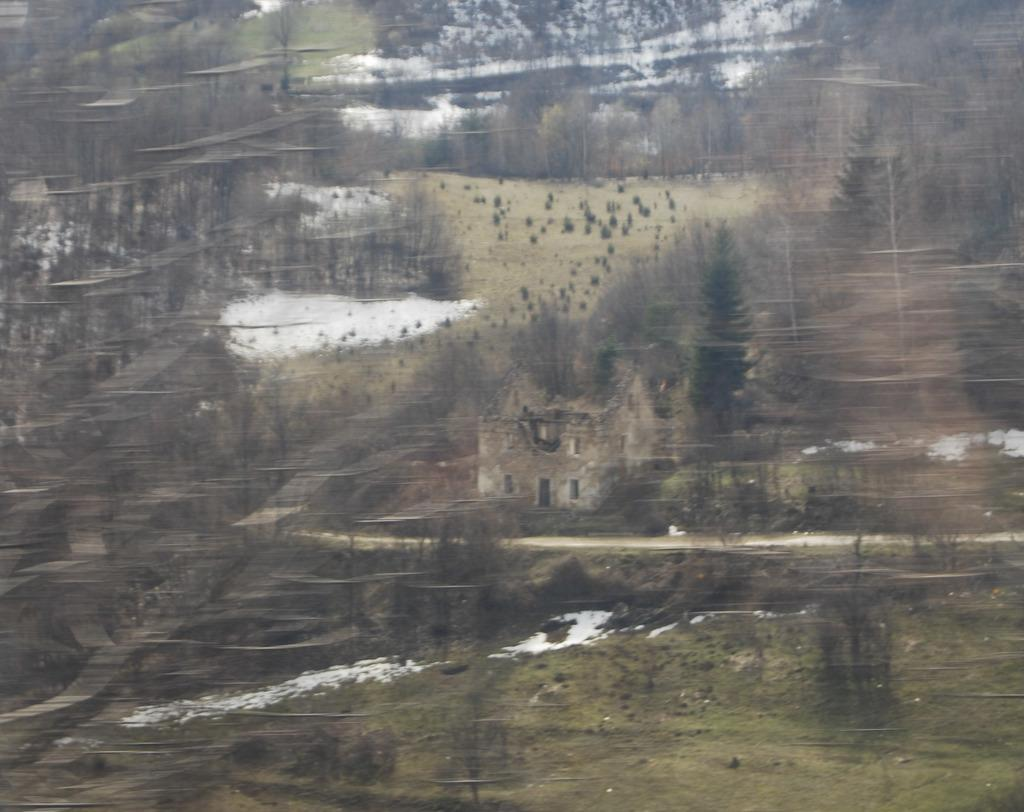What type of artwork is depicted in the image? The image appears to be a painting or poster. What structure can be seen in the image? There is a small house in the image. What type of vegetation is present in the image? There are dry trees in the image. How many clocks are hanging on the walls of the small house in the image? There is no mention of clocks or walls in the image, so it is not possible to answer that question. 